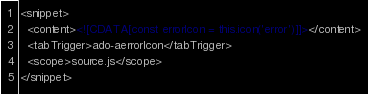<code> <loc_0><loc_0><loc_500><loc_500><_XML_><snippet>
  <content><![CDATA[const errorIcon = this.icon('error')]]></content>
  <tabTrigger>ado-aerrorIcon</tabTrigger>
  <scope>source.js</scope>
</snippet>
</code> 